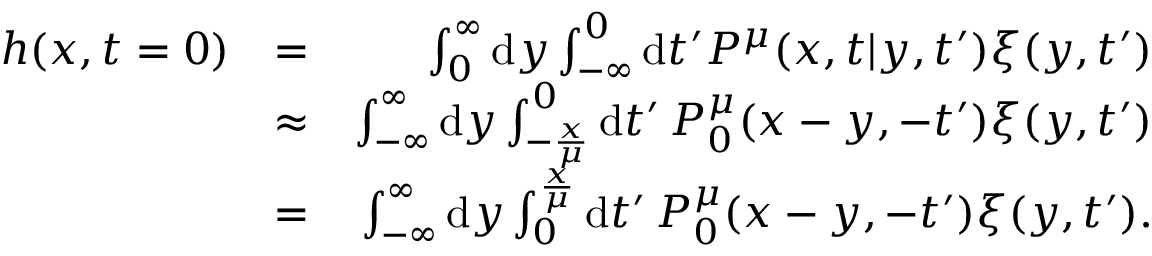Convert formula to latex. <formula><loc_0><loc_0><loc_500><loc_500>\begin{array} { r l r } { h ( x , t = 0 ) } & { = } & { \int _ { 0 } ^ { \infty } d y \int _ { - \infty } ^ { 0 } d t ^ { \prime } P ^ { \mu } ( x , t | y , t ^ { \prime } ) \xi ( y , t ^ { \prime } ) } \\ & { \approx } & { \int _ { - \infty } ^ { \infty } d y \int _ { - \frac { x } { \mu } } ^ { 0 } d t ^ { \prime } \, P _ { 0 } ^ { \mu } ( x - y , - t ^ { \prime } ) \xi ( y , t ^ { \prime } ) } \\ & { = } & { \int _ { - \infty } ^ { \infty } d y \int _ { 0 } ^ { \frac { x } { \mu } } d t ^ { \prime } \, P _ { 0 } ^ { \mu } ( x - y , - t ^ { \prime } ) \xi ( y , t ^ { \prime } ) . } \end{array}</formula> 